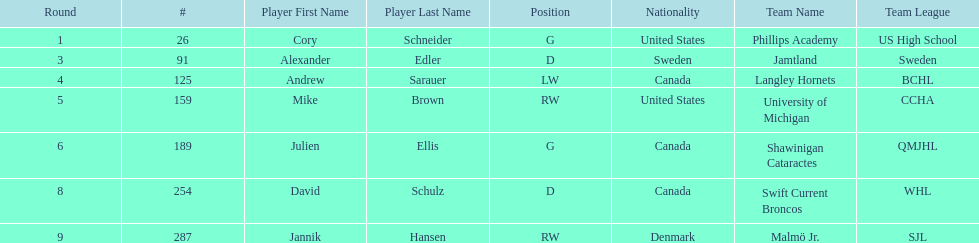List each player drafted from canada. Andrew Sarauer (LW), Julien Ellis (G), David Schulz (D). 